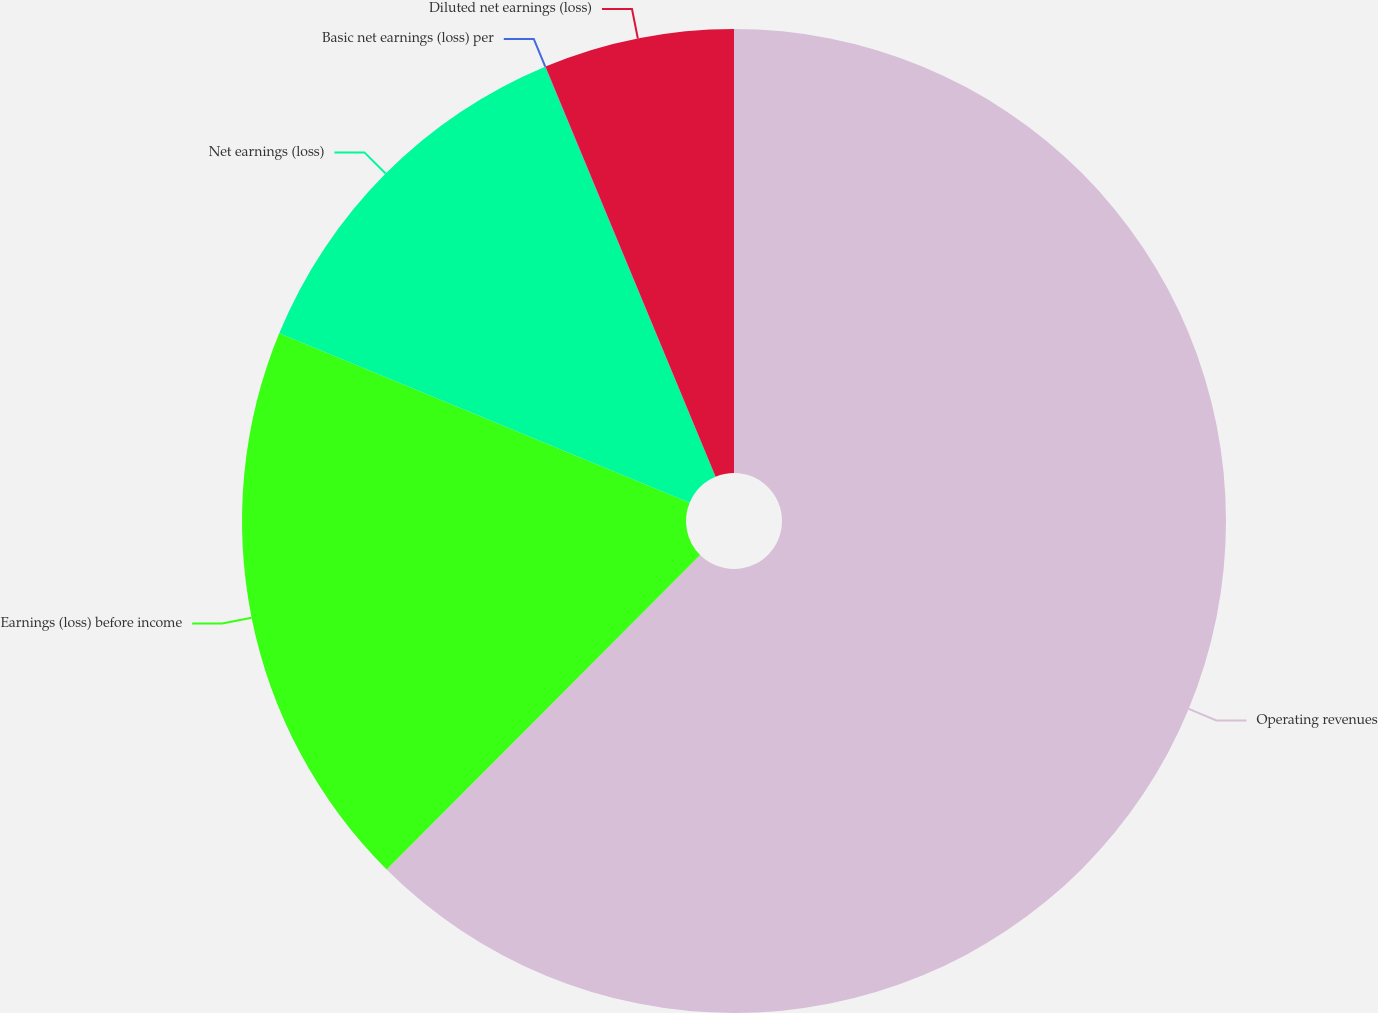Convert chart. <chart><loc_0><loc_0><loc_500><loc_500><pie_chart><fcel>Operating revenues<fcel>Earnings (loss) before income<fcel>Net earnings (loss)<fcel>Basic net earnings (loss) per<fcel>Diluted net earnings (loss)<nl><fcel>62.47%<fcel>18.75%<fcel>12.5%<fcel>0.01%<fcel>6.26%<nl></chart> 